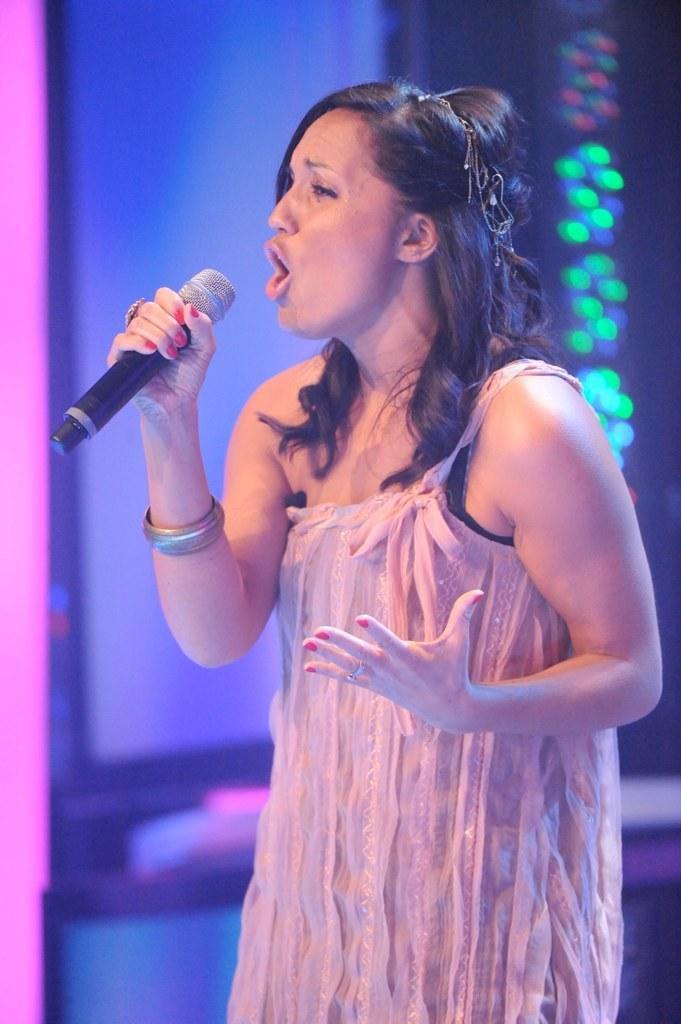Describe this image in one or two sentences. In this image one lady is singing, as her mouth is open. She is holding one mic. She is wearing a pink dress. In the background there is light. 